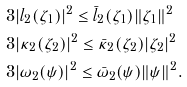<formula> <loc_0><loc_0><loc_500><loc_500>& 3 | l _ { 2 } ( \zeta _ { 1 } ) | ^ { 2 } \leq \bar { l } _ { 2 } ( \zeta _ { 1 } ) \| \zeta _ { 1 } \| ^ { 2 } \\ & 3 | \kappa _ { 2 } ( \zeta _ { 2 } ) | ^ { 2 } \leq \bar { \kappa } _ { 2 } ( \zeta _ { 2 } ) | \zeta _ { 2 } | ^ { 2 } \\ & 3 | \omega _ { 2 } ( \psi ) | ^ { 2 } \leq \bar { \omega } _ { 2 } ( \psi ) \| \psi \| ^ { 2 } .</formula> 